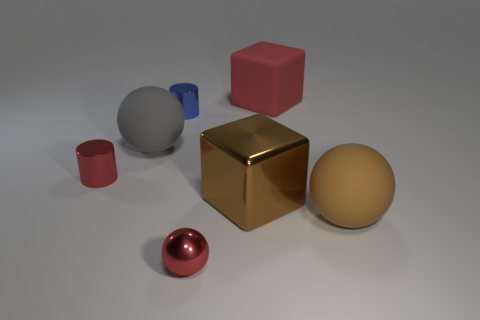There is a tiny object that is the same color as the tiny shiny sphere; what shape is it?
Offer a terse response. Cylinder. What is the material of the big sphere that is the same color as the metallic block?
Offer a terse response. Rubber. There is a gray thing that is the same size as the red matte block; what is it made of?
Keep it short and to the point. Rubber. The large block in front of the big sphere left of the big brown block is made of what material?
Give a very brief answer. Metal. The metal object that is behind the tiny cylinder that is to the left of the big matte sphere left of the brown sphere is what shape?
Ensure brevity in your answer.  Cylinder. There is a large gray object that is the same shape as the large brown rubber object; what material is it?
Provide a short and direct response. Rubber. How many big gray shiny balls are there?
Ensure brevity in your answer.  0. There is a thing in front of the brown sphere; what is its shape?
Provide a short and direct response. Sphere. There is a shiny thing that is in front of the rubber thing that is in front of the big matte object to the left of the large red cube; what is its color?
Provide a short and direct response. Red. What shape is the blue object that is the same material as the tiny ball?
Give a very brief answer. Cylinder. 